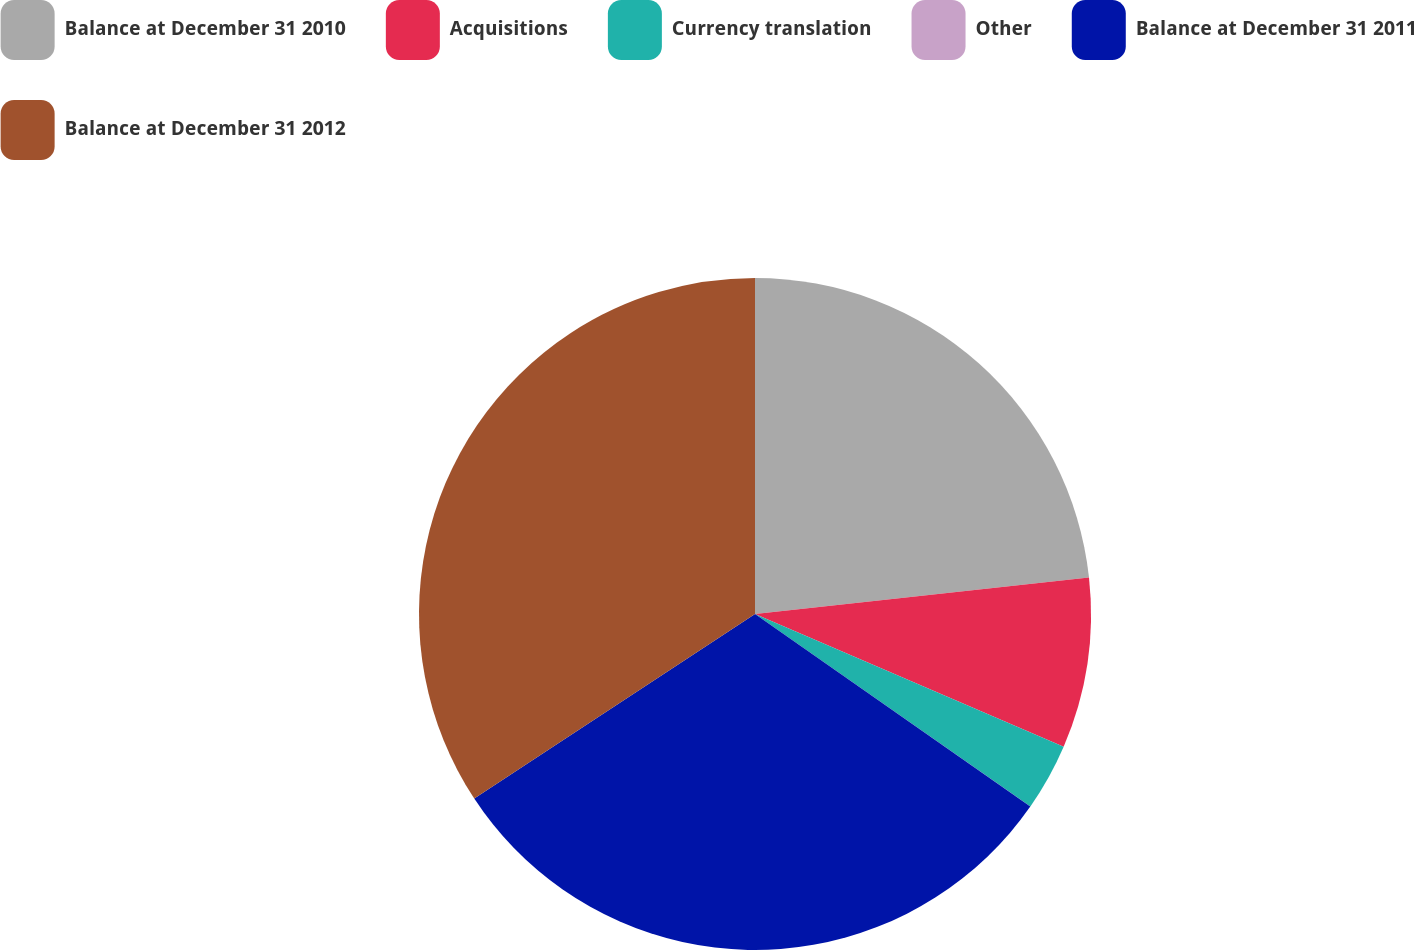<chart> <loc_0><loc_0><loc_500><loc_500><pie_chart><fcel>Balance at December 31 2010<fcel>Acquisitions<fcel>Currency translation<fcel>Other<fcel>Balance at December 31 2011<fcel>Balance at December 31 2012<nl><fcel>23.27%<fcel>8.2%<fcel>3.24%<fcel>0.01%<fcel>31.03%<fcel>34.26%<nl></chart> 